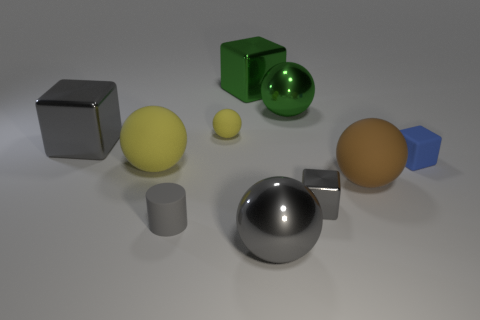Subtract all big green cubes. How many cubes are left? 3 Subtract all purple spheres. How many gray cubes are left? 2 Subtract all blocks. How many objects are left? 6 Subtract 3 balls. How many balls are left? 2 Add 4 big gray cubes. How many big gray cubes exist? 5 Subtract all green balls. How many balls are left? 4 Subtract 0 purple spheres. How many objects are left? 10 Subtract all green cylinders. Subtract all green blocks. How many cylinders are left? 1 Subtract all big metallic objects. Subtract all balls. How many objects are left? 1 Add 5 gray blocks. How many gray blocks are left? 7 